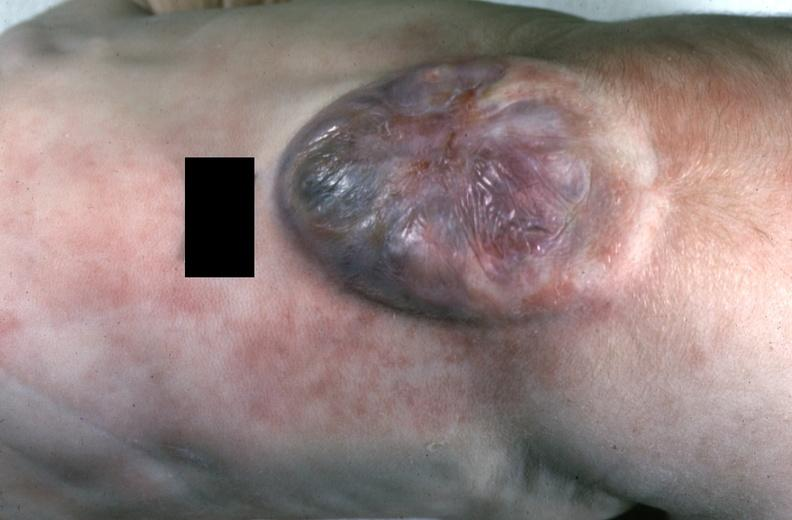what does this image show?
Answer the question using a single word or phrase. Neural tube defect 